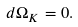Convert formula to latex. <formula><loc_0><loc_0><loc_500><loc_500>d \Omega _ { K } = 0 .</formula> 